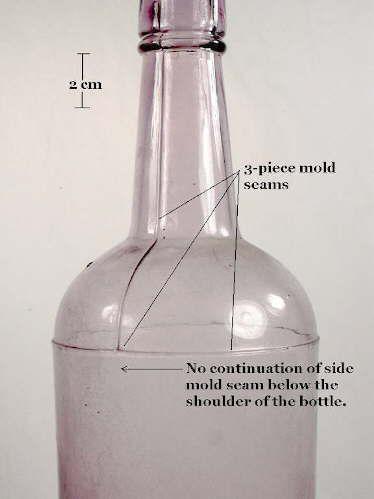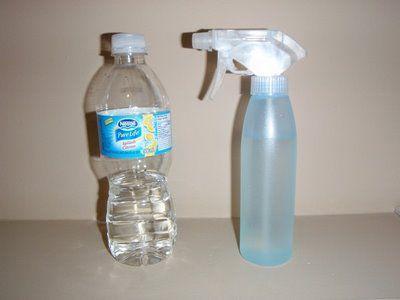The first image is the image on the left, the second image is the image on the right. Given the left and right images, does the statement "Three water bottles with blue caps are in a row." hold true? Answer yes or no. No. The first image is the image on the left, the second image is the image on the right. Analyze the images presented: Is the assertion "The left image contains no more than one bottle." valid? Answer yes or no. Yes. 